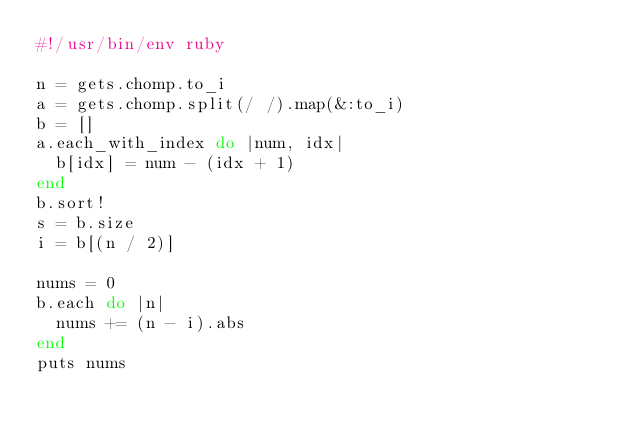Convert code to text. <code><loc_0><loc_0><loc_500><loc_500><_Ruby_>#!/usr/bin/env ruby

n = gets.chomp.to_i
a = gets.chomp.split(/ /).map(&:to_i)
b = []
a.each_with_index do |num, idx|
  b[idx] = num - (idx + 1)
end
b.sort!
s = b.size
i = b[(n / 2)]

nums = 0
b.each do |n|
  nums += (n - i).abs
end
puts nums
</code> 